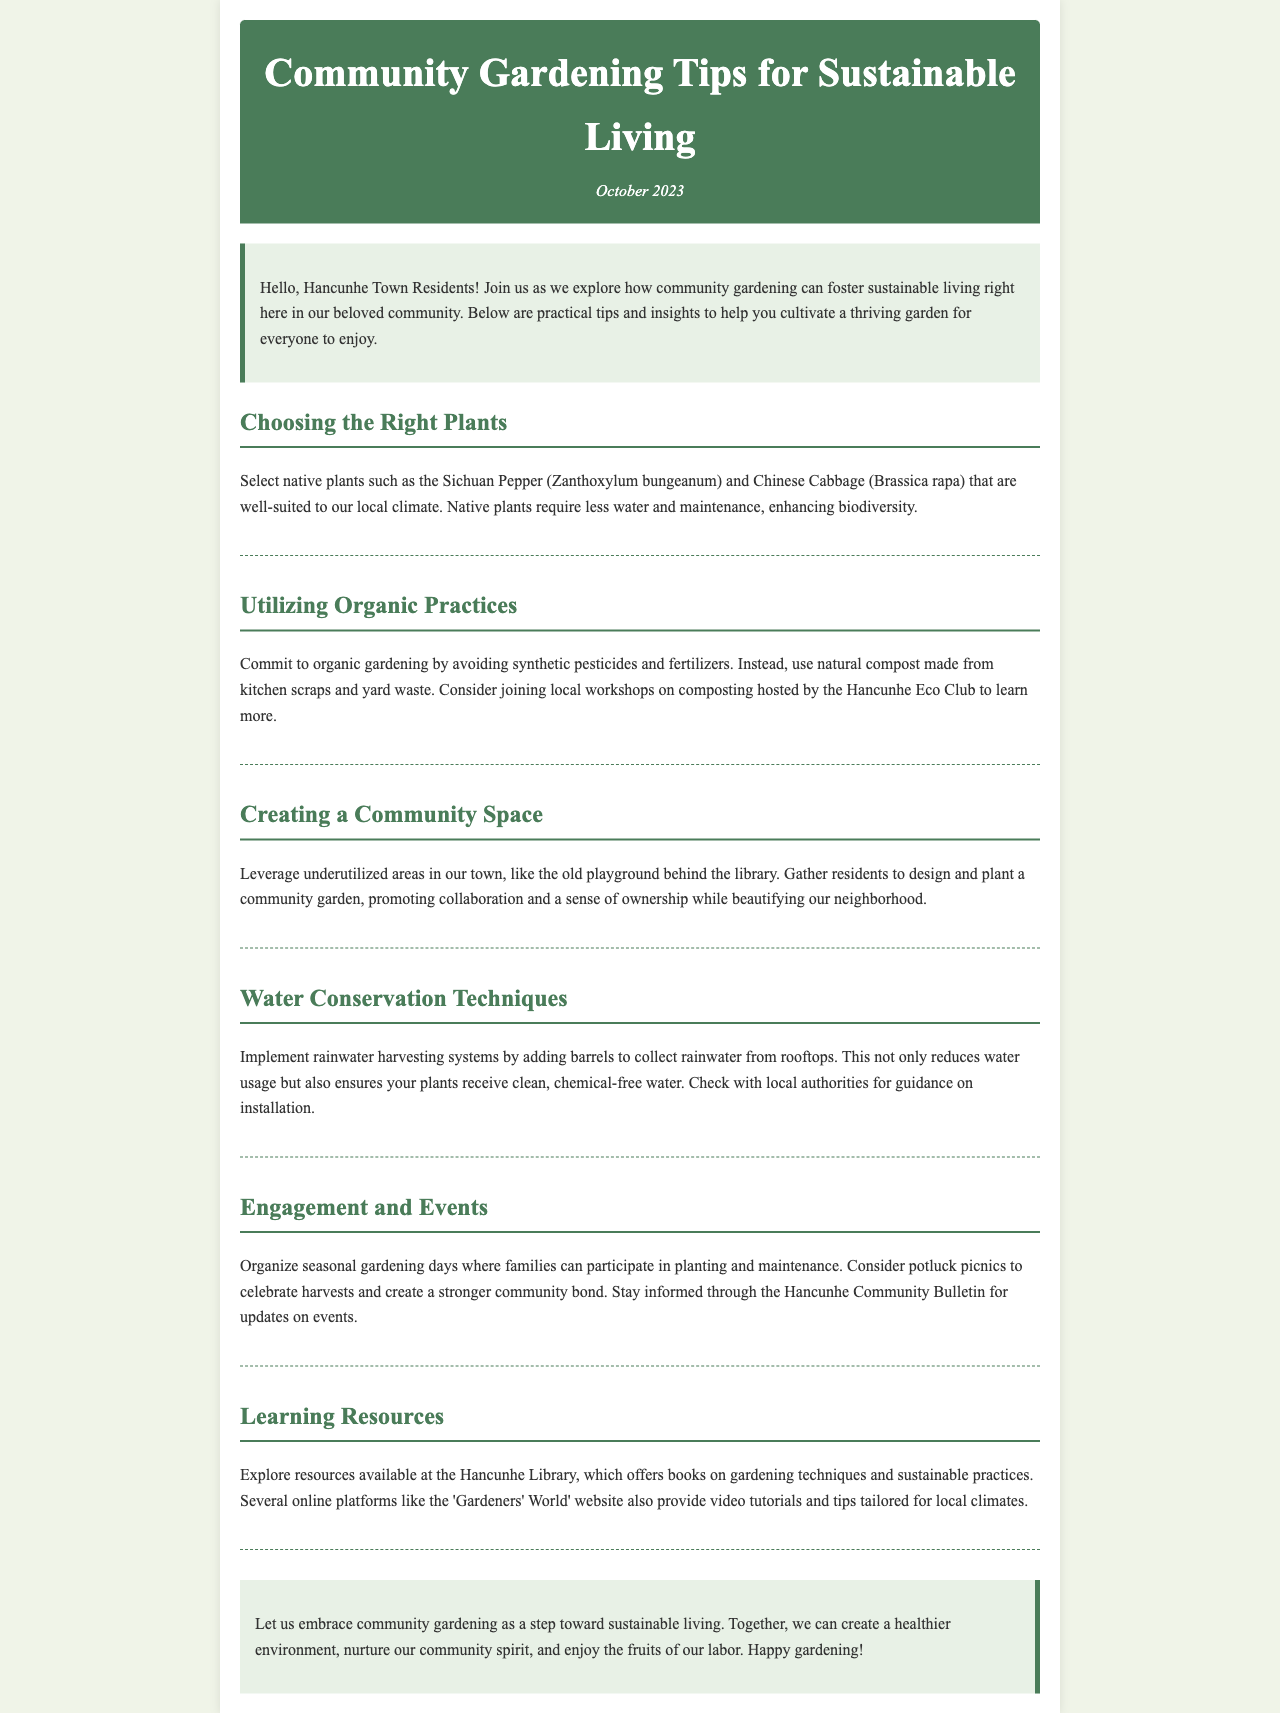What is the title of the newsletter? The title of the newsletter is clearly stated at the top of the document.
Answer: Community Gardening Tips for Sustainable Living What plant is native to our local climate? The document mentions a specific native plant that is well-suited for the local climate.
Answer: Sichuan Pepper What type of gardening practices does the newsletter suggest avoiding? The newsletter advises against a specific type of gardening practices that involve chemicals.
Answer: Synthetic pesticides Where can a community garden be designed and planted? The document suggests a specific location in the town for creating a community garden.
Answer: Old playground behind the library What water conservation system is recommended? The recommendation in the document for conserving water involves collecting rainwater.
Answer: Rainwater harvesting systems Which club offers composting workshops? The document specifies a local organization that hosts workshops related to composting.
Answer: Hancunhe Eco Club What seasonal events does the newsletter suggest organizing? The newsletter proposes a type of event that engages the community in gardening.
Answer: Gardening days What resource is available for learning about gardening techniques? The document mentions a specific place that offers resources for gardening.
Answer: Hancunhe Library 